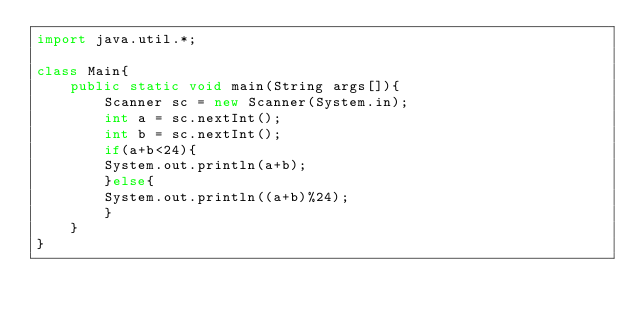Convert code to text. <code><loc_0><loc_0><loc_500><loc_500><_Java_>import java.util.*;

class Main{
    public static void main(String args[]){
        Scanner sc = new Scanner(System.in);
        int a = sc.nextInt();
        int b = sc.nextInt();
        if(a+b<24){
        System.out.println(a+b);
        }else{
        System.out.println((a+b)%24);    
        }
    }
}</code> 